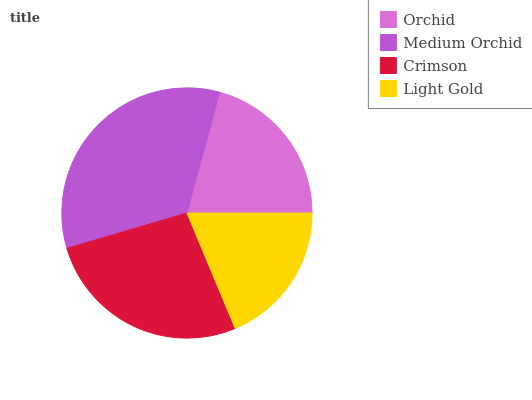Is Light Gold the minimum?
Answer yes or no. Yes. Is Medium Orchid the maximum?
Answer yes or no. Yes. Is Crimson the minimum?
Answer yes or no. No. Is Crimson the maximum?
Answer yes or no. No. Is Medium Orchid greater than Crimson?
Answer yes or no. Yes. Is Crimson less than Medium Orchid?
Answer yes or no. Yes. Is Crimson greater than Medium Orchid?
Answer yes or no. No. Is Medium Orchid less than Crimson?
Answer yes or no. No. Is Crimson the high median?
Answer yes or no. Yes. Is Orchid the low median?
Answer yes or no. Yes. Is Orchid the high median?
Answer yes or no. No. Is Crimson the low median?
Answer yes or no. No. 